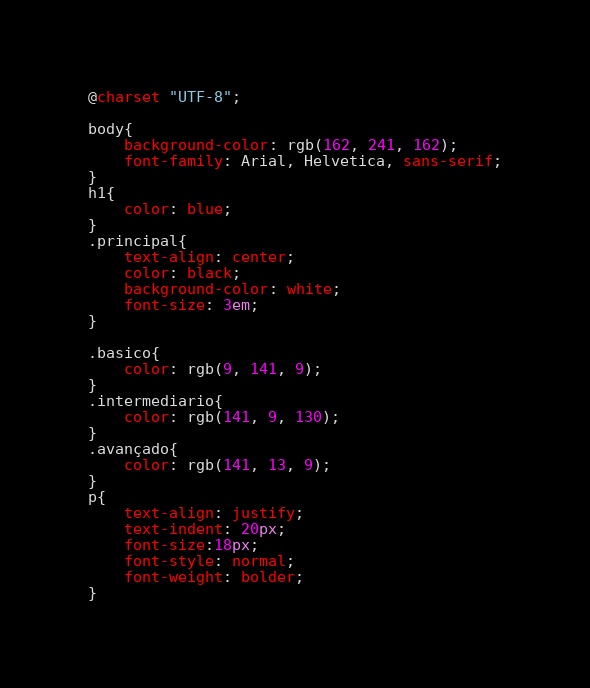<code> <loc_0><loc_0><loc_500><loc_500><_CSS_>@charset "UTF-8";

body{
    background-color: rgb(162, 241, 162);
    font-family: Arial, Helvetica, sans-serif;
}
h1{
    color: blue;
}
.principal{
    text-align: center;
    color: black;
    background-color: white;
    font-size: 3em;
}

.basico{
    color: rgb(9, 141, 9);
}
.intermediario{
    color: rgb(141, 9, 130);
}
.avançado{
    color: rgb(141, 13, 9);
}
p{
    text-align: justify;
    text-indent: 20px;
    font-size:18px;
    font-style: normal;
    font-weight: bolder;
}</code> 